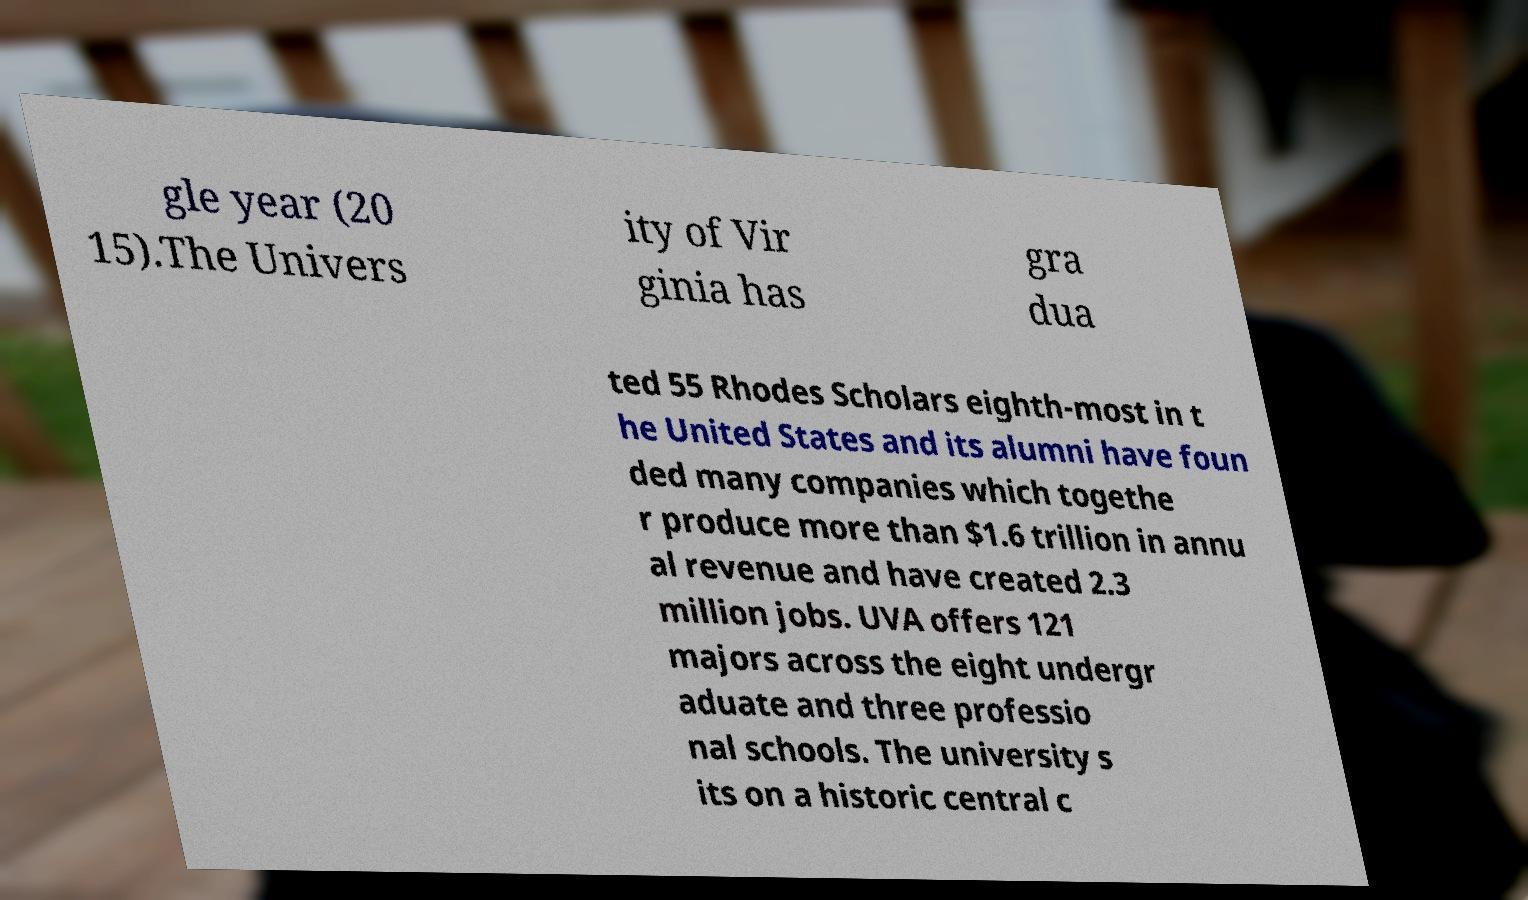Can you accurately transcribe the text from the provided image for me? gle year (20 15).The Univers ity of Vir ginia has gra dua ted 55 Rhodes Scholars eighth-most in t he United States and its alumni have foun ded many companies which togethe r produce more than $1.6 trillion in annu al revenue and have created 2.3 million jobs. UVA offers 121 majors across the eight undergr aduate and three professio nal schools. The university s its on a historic central c 